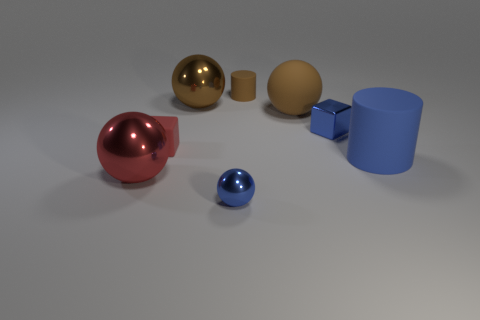What number of brown matte things are to the right of the blue object that is on the right side of the tiny metallic thing to the right of the blue sphere?
Make the answer very short. 0. Does the large brown rubber thing have the same shape as the tiny red object?
Make the answer very short. No. Are there any cyan things of the same shape as the red metal object?
Your response must be concise. No. What shape is the red object that is the same size as the brown metal sphere?
Make the answer very short. Sphere. The cylinder that is in front of the tiny object that is left of the object in front of the large red object is made of what material?
Provide a short and direct response. Rubber. Is the size of the matte sphere the same as the brown metal ball?
Ensure brevity in your answer.  Yes. What is the material of the blue cylinder?
Offer a very short reply. Rubber. There is another big ball that is the same color as the big matte sphere; what is it made of?
Provide a succinct answer. Metal. There is a tiny blue object in front of the red shiny sphere; does it have the same shape as the large blue thing?
Provide a succinct answer. No. How many things are either matte cylinders or small balls?
Your answer should be compact. 3. 